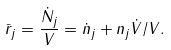<formula> <loc_0><loc_0><loc_500><loc_500>\bar { r } _ { j } = \frac { \dot { N } _ { j } } { V } = \dot { n } _ { j } + n _ { j } \dot { V } / V .</formula> 